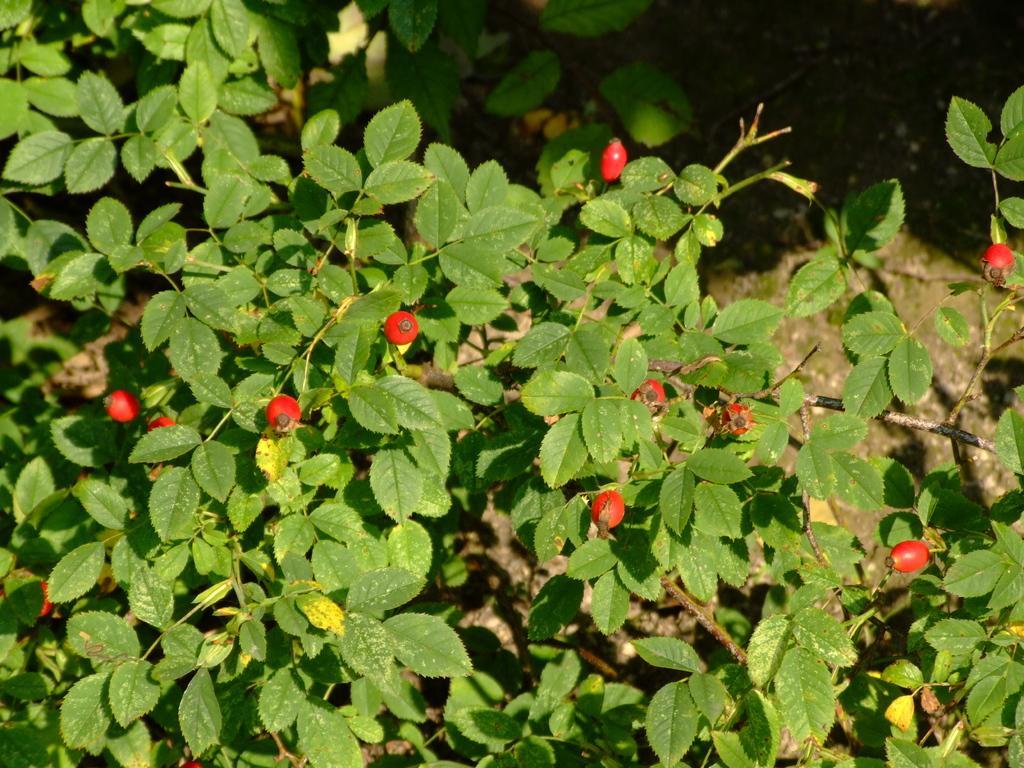How would you summarize this image in a sentence or two? In the image we can see some plants. 